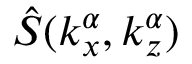Convert formula to latex. <formula><loc_0><loc_0><loc_500><loc_500>\hat { S } ( k _ { x } ^ { \alpha } , k _ { z } ^ { \alpha } )</formula> 